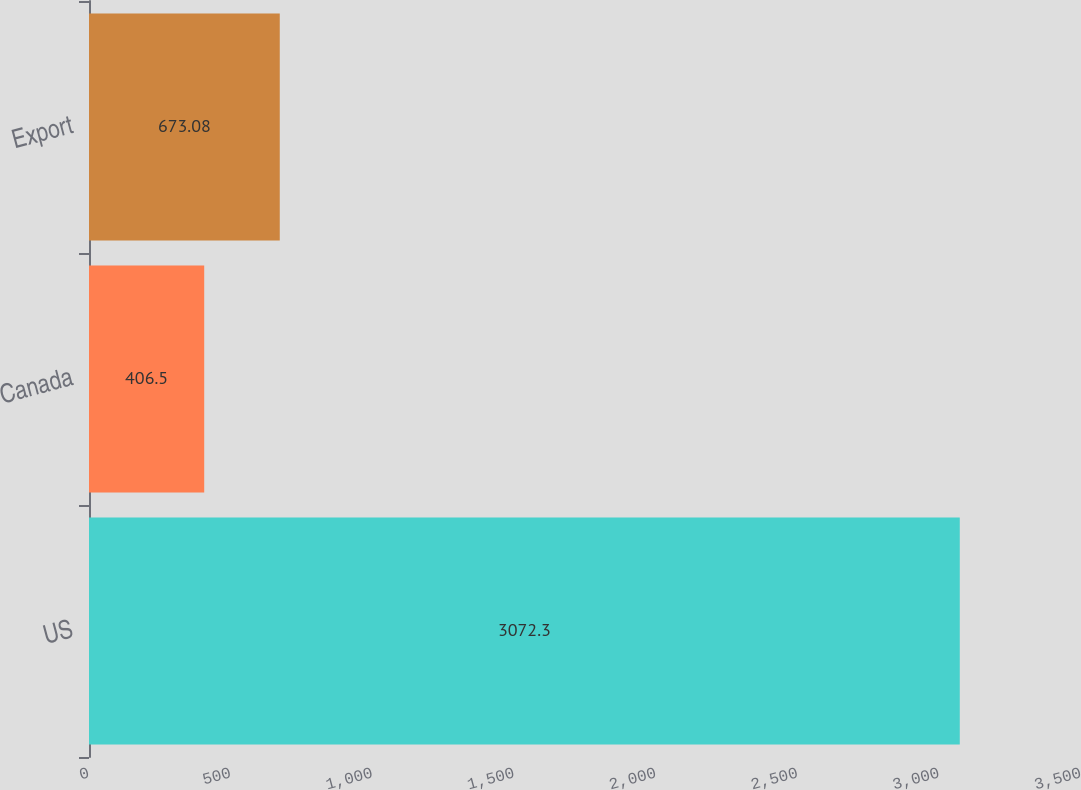<chart> <loc_0><loc_0><loc_500><loc_500><bar_chart><fcel>US<fcel>Canada<fcel>Export<nl><fcel>3072.3<fcel>406.5<fcel>673.08<nl></chart> 